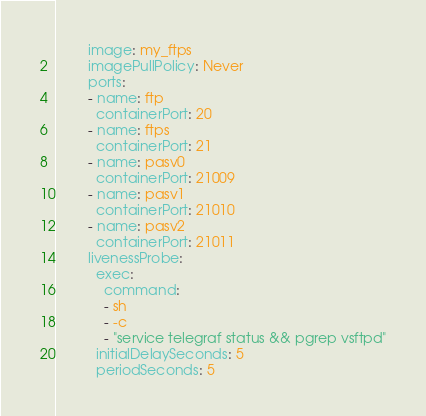Convert code to text. <code><loc_0><loc_0><loc_500><loc_500><_YAML_>        image: my_ftps
        imagePullPolicy: Never
        ports:
        - name: ftp
          containerPort: 20
        - name: ftps
          containerPort: 21
        - name: pasv0
          containerPort: 21009
        - name: pasv1
          containerPort: 21010
        - name: pasv2
          containerPort: 21011
        livenessProbe:
          exec:
            command:
            - sh
            - -c
            - "service telegraf status && pgrep vsftpd"
          initialDelaySeconds: 5
          periodSeconds: 5
</code> 